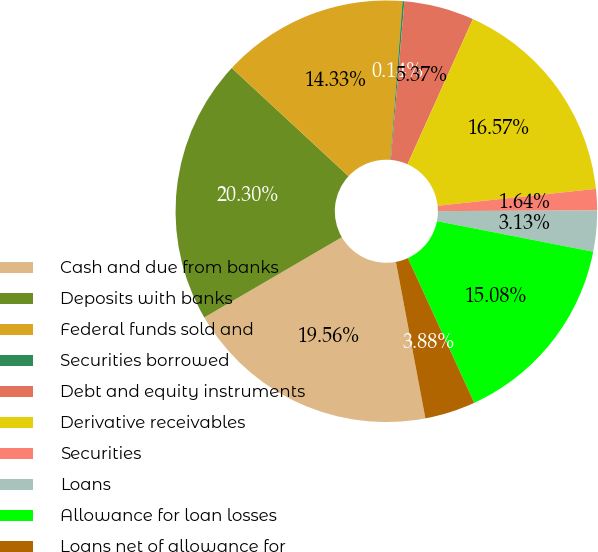<chart> <loc_0><loc_0><loc_500><loc_500><pie_chart><fcel>Cash and due from banks<fcel>Deposits with banks<fcel>Federal funds sold and<fcel>Securities borrowed<fcel>Debt and equity instruments<fcel>Derivative receivables<fcel>Securities<fcel>Loans<fcel>Allowance for loan losses<fcel>Loans net of allowance for<nl><fcel>19.56%<fcel>20.3%<fcel>14.33%<fcel>0.14%<fcel>5.37%<fcel>16.57%<fcel>1.64%<fcel>3.13%<fcel>15.08%<fcel>3.88%<nl></chart> 